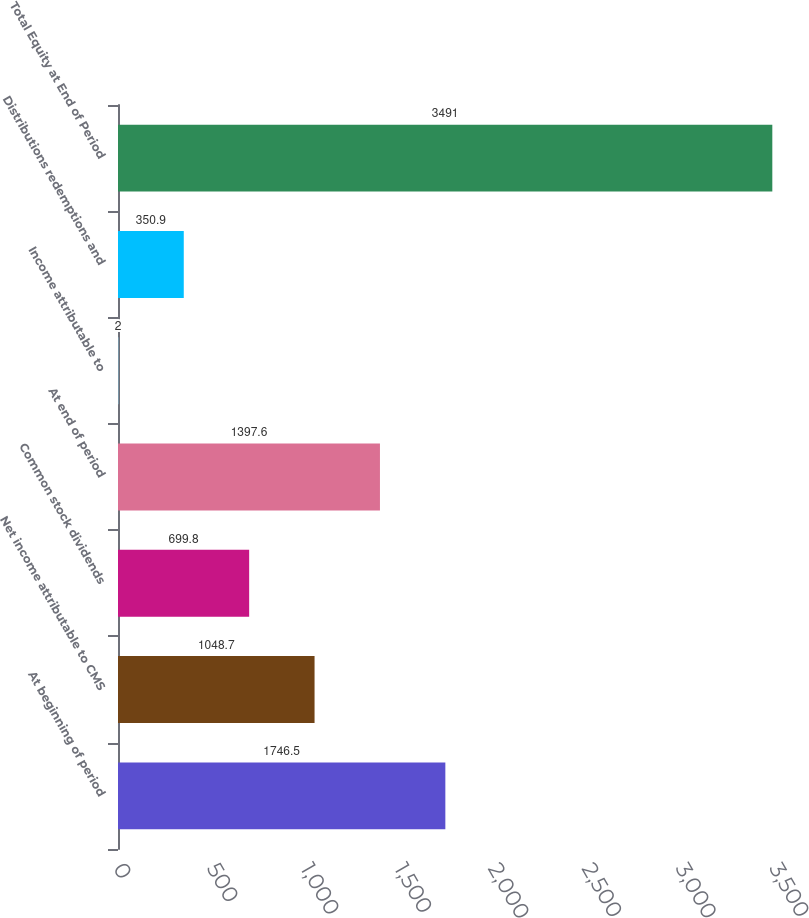Convert chart to OTSL. <chart><loc_0><loc_0><loc_500><loc_500><bar_chart><fcel>At beginning of period<fcel>Net income attributable to CMS<fcel>Common stock dividends<fcel>At end of period<fcel>Income attributable to<fcel>Distributions redemptions and<fcel>Total Equity at End of Period<nl><fcel>1746.5<fcel>1048.7<fcel>699.8<fcel>1397.6<fcel>2<fcel>350.9<fcel>3491<nl></chart> 